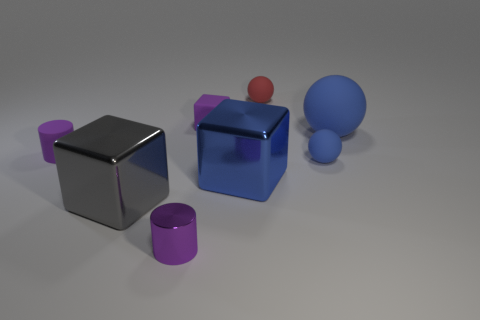There is a red ball that is the same size as the purple metal cylinder; what material is it?
Offer a terse response. Rubber. Are there any blue cubes made of the same material as the big blue ball?
Your response must be concise. No. There is a small red thing; does it have the same shape as the large gray metallic object on the left side of the small purple cube?
Your answer should be compact. No. What number of small objects are both in front of the tiny block and on the right side of the purple cube?
Provide a short and direct response. 1. Are the small red object and the large object that is on the right side of the small red matte thing made of the same material?
Ensure brevity in your answer.  Yes. Are there an equal number of matte balls in front of the shiny cylinder and big objects?
Provide a succinct answer. No. What color is the small rubber sphere that is in front of the small red rubber thing?
Keep it short and to the point. Blue. What number of other things are the same color as the tiny rubber cylinder?
Provide a short and direct response. 2. Is there anything else that has the same size as the gray shiny cube?
Ensure brevity in your answer.  Yes. There is a blue object on the left side of the red rubber sphere; is it the same size as the tiny purple matte cylinder?
Make the answer very short. No. 